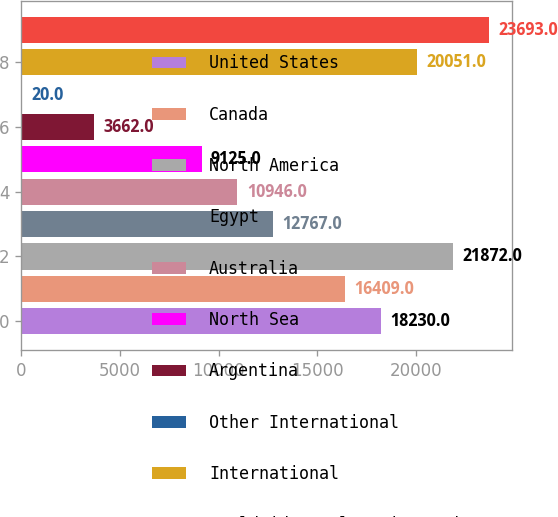<chart> <loc_0><loc_0><loc_500><loc_500><bar_chart><fcel>United States<fcel>Canada<fcel>North America<fcel>Egypt<fcel>Australia<fcel>North Sea<fcel>Argentina<fcel>Other International<fcel>International<fcel>Worldwide Exploration and<nl><fcel>18230<fcel>16409<fcel>21872<fcel>12767<fcel>10946<fcel>9125<fcel>3662<fcel>20<fcel>20051<fcel>23693<nl></chart> 